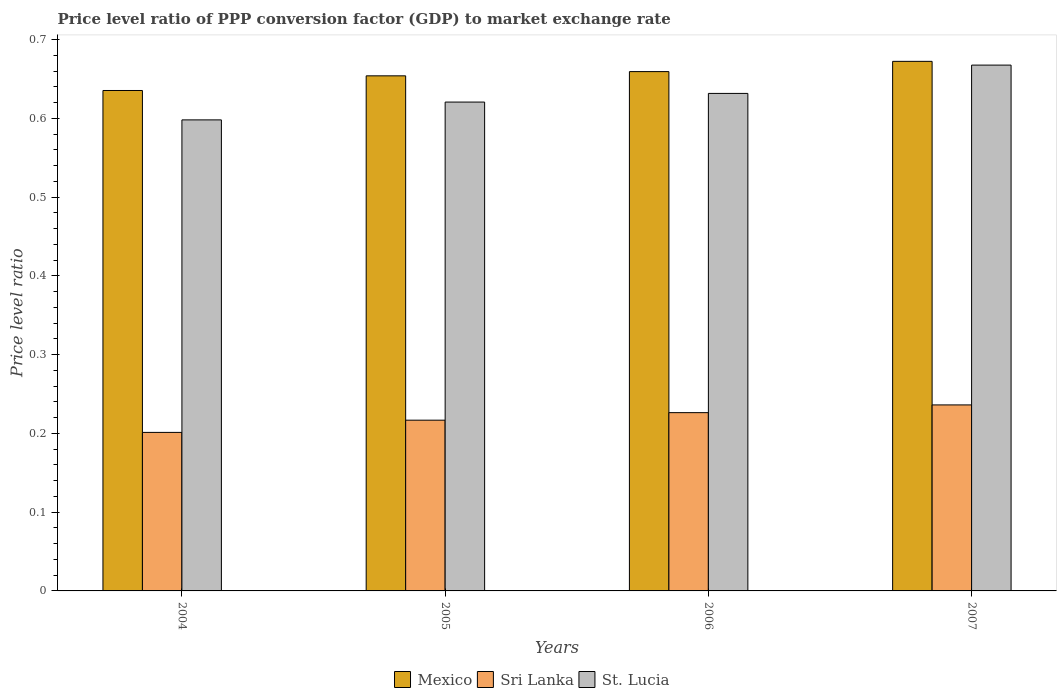How many different coloured bars are there?
Offer a terse response. 3. How many groups of bars are there?
Provide a short and direct response. 4. Are the number of bars per tick equal to the number of legend labels?
Your answer should be compact. Yes. In how many cases, is the number of bars for a given year not equal to the number of legend labels?
Make the answer very short. 0. What is the price level ratio in Mexico in 2005?
Your answer should be very brief. 0.65. Across all years, what is the maximum price level ratio in St. Lucia?
Ensure brevity in your answer.  0.67. Across all years, what is the minimum price level ratio in Mexico?
Your answer should be very brief. 0.64. What is the total price level ratio in St. Lucia in the graph?
Keep it short and to the point. 2.52. What is the difference between the price level ratio in Mexico in 2005 and that in 2006?
Give a very brief answer. -0.01. What is the difference between the price level ratio in Sri Lanka in 2007 and the price level ratio in St. Lucia in 2006?
Keep it short and to the point. -0.4. What is the average price level ratio in Sri Lanka per year?
Provide a succinct answer. 0.22. In the year 2006, what is the difference between the price level ratio in St. Lucia and price level ratio in Mexico?
Your answer should be compact. -0.03. What is the ratio of the price level ratio in St. Lucia in 2005 to that in 2007?
Offer a terse response. 0.93. What is the difference between the highest and the second highest price level ratio in Mexico?
Give a very brief answer. 0.01. What is the difference between the highest and the lowest price level ratio in Sri Lanka?
Your response must be concise. 0.03. In how many years, is the price level ratio in St. Lucia greater than the average price level ratio in St. Lucia taken over all years?
Ensure brevity in your answer.  2. What does the 2nd bar from the left in 2004 represents?
Give a very brief answer. Sri Lanka. What does the 3rd bar from the right in 2004 represents?
Keep it short and to the point. Mexico. Is it the case that in every year, the sum of the price level ratio in Sri Lanka and price level ratio in Mexico is greater than the price level ratio in St. Lucia?
Provide a short and direct response. Yes. Are all the bars in the graph horizontal?
Keep it short and to the point. No. How many years are there in the graph?
Keep it short and to the point. 4. Are the values on the major ticks of Y-axis written in scientific E-notation?
Ensure brevity in your answer.  No. How are the legend labels stacked?
Make the answer very short. Horizontal. What is the title of the graph?
Your response must be concise. Price level ratio of PPP conversion factor (GDP) to market exchange rate. Does "Guam" appear as one of the legend labels in the graph?
Your answer should be compact. No. What is the label or title of the Y-axis?
Your response must be concise. Price level ratio. What is the Price level ratio in Mexico in 2004?
Offer a very short reply. 0.64. What is the Price level ratio in Sri Lanka in 2004?
Ensure brevity in your answer.  0.2. What is the Price level ratio of St. Lucia in 2004?
Your response must be concise. 0.6. What is the Price level ratio of Mexico in 2005?
Your response must be concise. 0.65. What is the Price level ratio in Sri Lanka in 2005?
Your answer should be compact. 0.22. What is the Price level ratio of St. Lucia in 2005?
Give a very brief answer. 0.62. What is the Price level ratio in Mexico in 2006?
Offer a very short reply. 0.66. What is the Price level ratio in Sri Lanka in 2006?
Ensure brevity in your answer.  0.23. What is the Price level ratio of St. Lucia in 2006?
Your answer should be compact. 0.63. What is the Price level ratio in Mexico in 2007?
Make the answer very short. 0.67. What is the Price level ratio in Sri Lanka in 2007?
Your answer should be very brief. 0.24. What is the Price level ratio of St. Lucia in 2007?
Make the answer very short. 0.67. Across all years, what is the maximum Price level ratio of Mexico?
Your answer should be compact. 0.67. Across all years, what is the maximum Price level ratio in Sri Lanka?
Your response must be concise. 0.24. Across all years, what is the maximum Price level ratio of St. Lucia?
Make the answer very short. 0.67. Across all years, what is the minimum Price level ratio in Mexico?
Give a very brief answer. 0.64. Across all years, what is the minimum Price level ratio in Sri Lanka?
Your response must be concise. 0.2. Across all years, what is the minimum Price level ratio of St. Lucia?
Provide a succinct answer. 0.6. What is the total Price level ratio of Mexico in the graph?
Your response must be concise. 2.62. What is the total Price level ratio of Sri Lanka in the graph?
Provide a short and direct response. 0.88. What is the total Price level ratio of St. Lucia in the graph?
Provide a short and direct response. 2.52. What is the difference between the Price level ratio of Mexico in 2004 and that in 2005?
Offer a very short reply. -0.02. What is the difference between the Price level ratio of Sri Lanka in 2004 and that in 2005?
Make the answer very short. -0.02. What is the difference between the Price level ratio in St. Lucia in 2004 and that in 2005?
Give a very brief answer. -0.02. What is the difference between the Price level ratio of Mexico in 2004 and that in 2006?
Provide a short and direct response. -0.02. What is the difference between the Price level ratio in Sri Lanka in 2004 and that in 2006?
Provide a short and direct response. -0.03. What is the difference between the Price level ratio of St. Lucia in 2004 and that in 2006?
Ensure brevity in your answer.  -0.03. What is the difference between the Price level ratio of Mexico in 2004 and that in 2007?
Your answer should be compact. -0.04. What is the difference between the Price level ratio of Sri Lanka in 2004 and that in 2007?
Ensure brevity in your answer.  -0.03. What is the difference between the Price level ratio of St. Lucia in 2004 and that in 2007?
Your answer should be very brief. -0.07. What is the difference between the Price level ratio in Mexico in 2005 and that in 2006?
Offer a terse response. -0.01. What is the difference between the Price level ratio of Sri Lanka in 2005 and that in 2006?
Make the answer very short. -0.01. What is the difference between the Price level ratio of St. Lucia in 2005 and that in 2006?
Your answer should be compact. -0.01. What is the difference between the Price level ratio in Mexico in 2005 and that in 2007?
Your answer should be very brief. -0.02. What is the difference between the Price level ratio of Sri Lanka in 2005 and that in 2007?
Your response must be concise. -0.02. What is the difference between the Price level ratio of St. Lucia in 2005 and that in 2007?
Your answer should be very brief. -0.05. What is the difference between the Price level ratio of Mexico in 2006 and that in 2007?
Make the answer very short. -0.01. What is the difference between the Price level ratio in Sri Lanka in 2006 and that in 2007?
Provide a succinct answer. -0.01. What is the difference between the Price level ratio of St. Lucia in 2006 and that in 2007?
Make the answer very short. -0.04. What is the difference between the Price level ratio in Mexico in 2004 and the Price level ratio in Sri Lanka in 2005?
Your answer should be compact. 0.42. What is the difference between the Price level ratio in Mexico in 2004 and the Price level ratio in St. Lucia in 2005?
Your response must be concise. 0.01. What is the difference between the Price level ratio of Sri Lanka in 2004 and the Price level ratio of St. Lucia in 2005?
Provide a succinct answer. -0.42. What is the difference between the Price level ratio in Mexico in 2004 and the Price level ratio in Sri Lanka in 2006?
Your response must be concise. 0.41. What is the difference between the Price level ratio in Mexico in 2004 and the Price level ratio in St. Lucia in 2006?
Make the answer very short. 0. What is the difference between the Price level ratio in Sri Lanka in 2004 and the Price level ratio in St. Lucia in 2006?
Give a very brief answer. -0.43. What is the difference between the Price level ratio in Mexico in 2004 and the Price level ratio in Sri Lanka in 2007?
Offer a terse response. 0.4. What is the difference between the Price level ratio of Mexico in 2004 and the Price level ratio of St. Lucia in 2007?
Offer a very short reply. -0.03. What is the difference between the Price level ratio in Sri Lanka in 2004 and the Price level ratio in St. Lucia in 2007?
Offer a terse response. -0.47. What is the difference between the Price level ratio of Mexico in 2005 and the Price level ratio of Sri Lanka in 2006?
Offer a very short reply. 0.43. What is the difference between the Price level ratio of Mexico in 2005 and the Price level ratio of St. Lucia in 2006?
Your response must be concise. 0.02. What is the difference between the Price level ratio in Sri Lanka in 2005 and the Price level ratio in St. Lucia in 2006?
Make the answer very short. -0.41. What is the difference between the Price level ratio in Mexico in 2005 and the Price level ratio in Sri Lanka in 2007?
Make the answer very short. 0.42. What is the difference between the Price level ratio of Mexico in 2005 and the Price level ratio of St. Lucia in 2007?
Provide a short and direct response. -0.01. What is the difference between the Price level ratio of Sri Lanka in 2005 and the Price level ratio of St. Lucia in 2007?
Make the answer very short. -0.45. What is the difference between the Price level ratio of Mexico in 2006 and the Price level ratio of Sri Lanka in 2007?
Your response must be concise. 0.42. What is the difference between the Price level ratio of Mexico in 2006 and the Price level ratio of St. Lucia in 2007?
Your answer should be very brief. -0.01. What is the difference between the Price level ratio of Sri Lanka in 2006 and the Price level ratio of St. Lucia in 2007?
Provide a short and direct response. -0.44. What is the average Price level ratio in Mexico per year?
Give a very brief answer. 0.66. What is the average Price level ratio in Sri Lanka per year?
Offer a very short reply. 0.22. What is the average Price level ratio in St. Lucia per year?
Give a very brief answer. 0.63. In the year 2004, what is the difference between the Price level ratio in Mexico and Price level ratio in Sri Lanka?
Your answer should be very brief. 0.43. In the year 2004, what is the difference between the Price level ratio of Mexico and Price level ratio of St. Lucia?
Keep it short and to the point. 0.04. In the year 2004, what is the difference between the Price level ratio in Sri Lanka and Price level ratio in St. Lucia?
Your answer should be very brief. -0.4. In the year 2005, what is the difference between the Price level ratio of Mexico and Price level ratio of Sri Lanka?
Give a very brief answer. 0.44. In the year 2005, what is the difference between the Price level ratio in Sri Lanka and Price level ratio in St. Lucia?
Give a very brief answer. -0.4. In the year 2006, what is the difference between the Price level ratio in Mexico and Price level ratio in Sri Lanka?
Your response must be concise. 0.43. In the year 2006, what is the difference between the Price level ratio in Mexico and Price level ratio in St. Lucia?
Provide a short and direct response. 0.03. In the year 2006, what is the difference between the Price level ratio of Sri Lanka and Price level ratio of St. Lucia?
Your answer should be compact. -0.41. In the year 2007, what is the difference between the Price level ratio in Mexico and Price level ratio in Sri Lanka?
Ensure brevity in your answer.  0.44. In the year 2007, what is the difference between the Price level ratio of Mexico and Price level ratio of St. Lucia?
Provide a short and direct response. 0. In the year 2007, what is the difference between the Price level ratio of Sri Lanka and Price level ratio of St. Lucia?
Provide a succinct answer. -0.43. What is the ratio of the Price level ratio of Mexico in 2004 to that in 2005?
Your answer should be compact. 0.97. What is the ratio of the Price level ratio of Sri Lanka in 2004 to that in 2005?
Provide a short and direct response. 0.93. What is the ratio of the Price level ratio in St. Lucia in 2004 to that in 2005?
Your answer should be compact. 0.96. What is the ratio of the Price level ratio in Mexico in 2004 to that in 2006?
Give a very brief answer. 0.96. What is the ratio of the Price level ratio of Sri Lanka in 2004 to that in 2006?
Provide a succinct answer. 0.89. What is the ratio of the Price level ratio of St. Lucia in 2004 to that in 2006?
Provide a succinct answer. 0.95. What is the ratio of the Price level ratio of Mexico in 2004 to that in 2007?
Keep it short and to the point. 0.94. What is the ratio of the Price level ratio of Sri Lanka in 2004 to that in 2007?
Your response must be concise. 0.85. What is the ratio of the Price level ratio in St. Lucia in 2004 to that in 2007?
Provide a short and direct response. 0.9. What is the ratio of the Price level ratio in Mexico in 2005 to that in 2006?
Make the answer very short. 0.99. What is the ratio of the Price level ratio in Sri Lanka in 2005 to that in 2006?
Your response must be concise. 0.96. What is the ratio of the Price level ratio of St. Lucia in 2005 to that in 2006?
Offer a terse response. 0.98. What is the ratio of the Price level ratio in Mexico in 2005 to that in 2007?
Your response must be concise. 0.97. What is the ratio of the Price level ratio in Sri Lanka in 2005 to that in 2007?
Offer a very short reply. 0.92. What is the ratio of the Price level ratio in St. Lucia in 2005 to that in 2007?
Give a very brief answer. 0.93. What is the ratio of the Price level ratio of Mexico in 2006 to that in 2007?
Ensure brevity in your answer.  0.98. What is the ratio of the Price level ratio in Sri Lanka in 2006 to that in 2007?
Ensure brevity in your answer.  0.96. What is the ratio of the Price level ratio of St. Lucia in 2006 to that in 2007?
Give a very brief answer. 0.95. What is the difference between the highest and the second highest Price level ratio in Mexico?
Your answer should be very brief. 0.01. What is the difference between the highest and the second highest Price level ratio of Sri Lanka?
Your response must be concise. 0.01. What is the difference between the highest and the second highest Price level ratio of St. Lucia?
Offer a very short reply. 0.04. What is the difference between the highest and the lowest Price level ratio of Mexico?
Ensure brevity in your answer.  0.04. What is the difference between the highest and the lowest Price level ratio in Sri Lanka?
Your response must be concise. 0.03. What is the difference between the highest and the lowest Price level ratio in St. Lucia?
Your answer should be very brief. 0.07. 